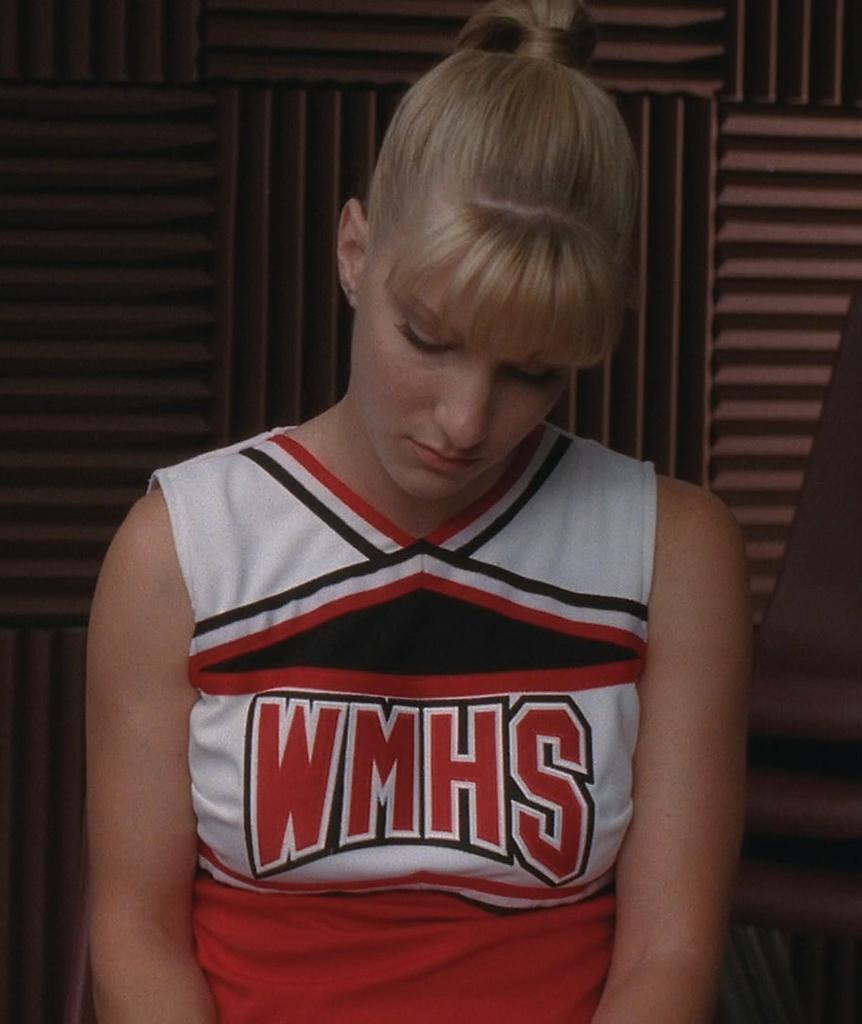Is she in junior high school?
Give a very brief answer. Unanswerable. 